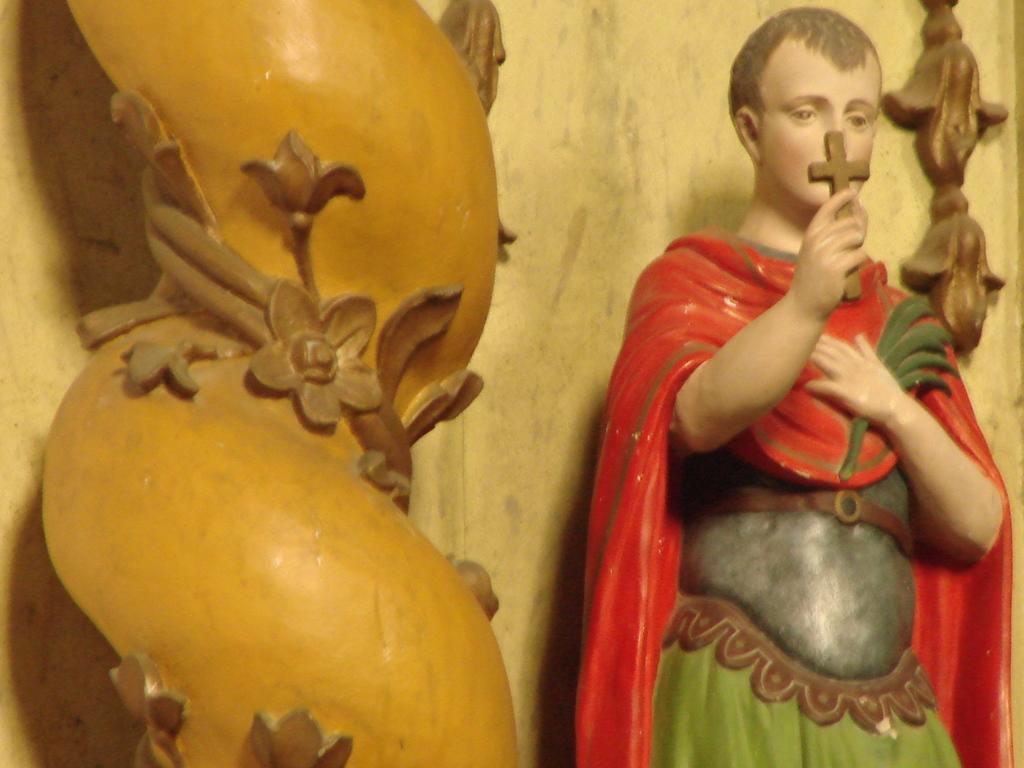What type of art is present in the image? The image contains sculptures. What is the person in the image holding? There is a person holding a cross in the image. What can be seen in the background of the image? There is a wall in the background of the image. Can you tell me how many fictional characters are depicted in the image? There is no mention of fictional characters in the image; it contains sculptures and a person holding a cross. Is there a lake visible in the image? There is no lake present in the image; it features sculptures, a person holding a cross, and a wall in the background. 